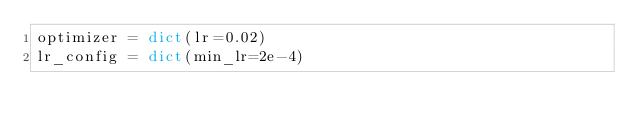<code> <loc_0><loc_0><loc_500><loc_500><_Python_>optimizer = dict(lr=0.02)
lr_config = dict(min_lr=2e-4)
</code> 